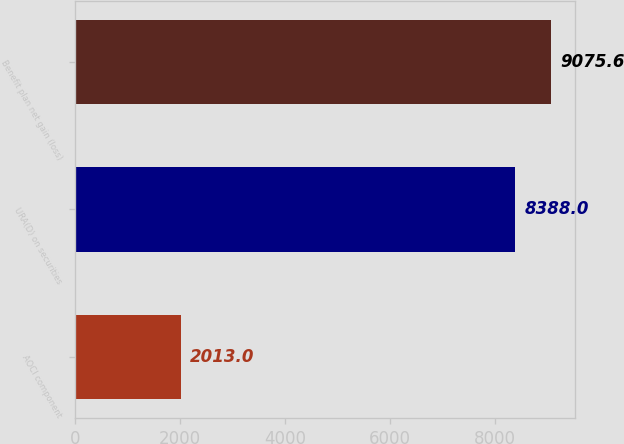Convert chart. <chart><loc_0><loc_0><loc_500><loc_500><bar_chart><fcel>AOCI component<fcel>URA(D) on securities<fcel>Benefit plan net gain (loss)<nl><fcel>2013<fcel>8388<fcel>9075.6<nl></chart> 